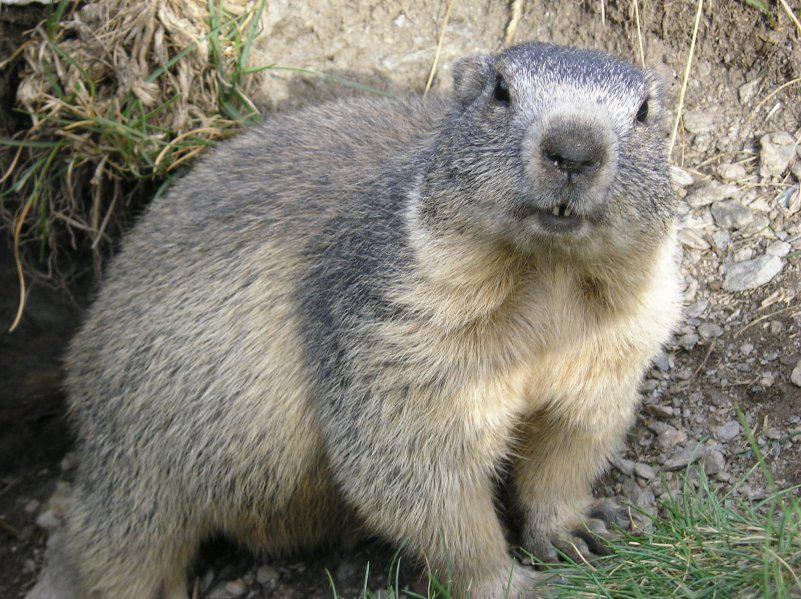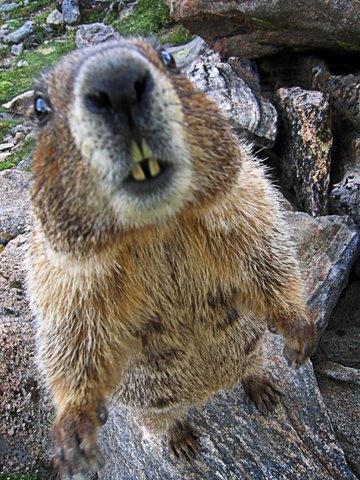The first image is the image on the left, the second image is the image on the right. Given the left and right images, does the statement "One image shows a rodent-type animal standing upright with front paws clasped together." hold true? Answer yes or no. No. 